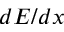Convert formula to latex. <formula><loc_0><loc_0><loc_500><loc_500>d E / d x</formula> 